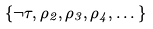<formula> <loc_0><loc_0><loc_500><loc_500>\{ \neg \tau , \rho _ { 2 } , \rho _ { 3 } , \rho _ { 4 } , \dots \}</formula> 